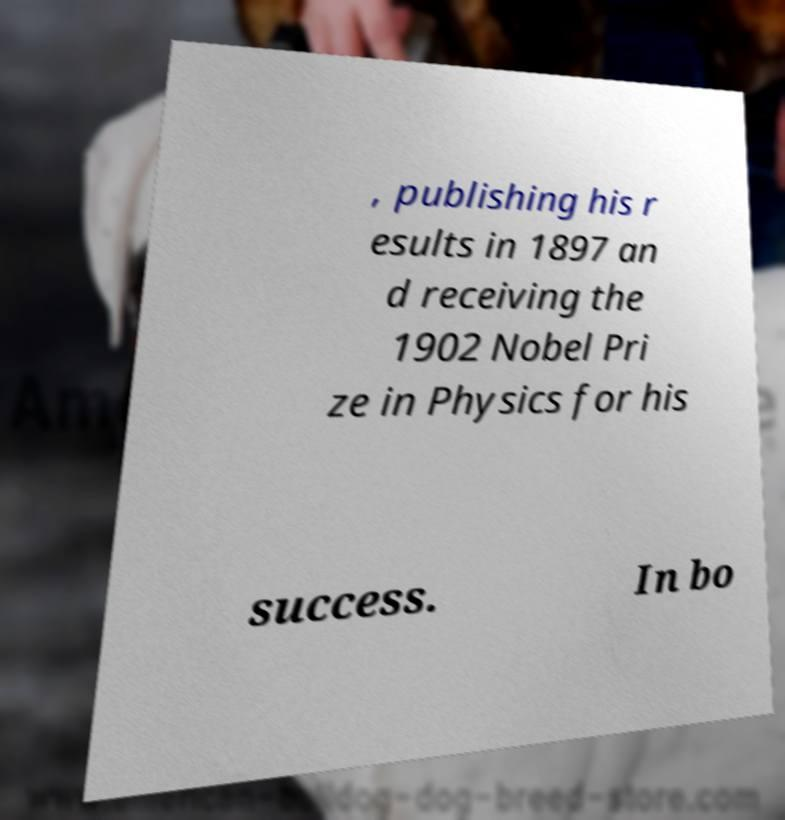Can you read and provide the text displayed in the image?This photo seems to have some interesting text. Can you extract and type it out for me? , publishing his r esults in 1897 an d receiving the 1902 Nobel Pri ze in Physics for his success. In bo 